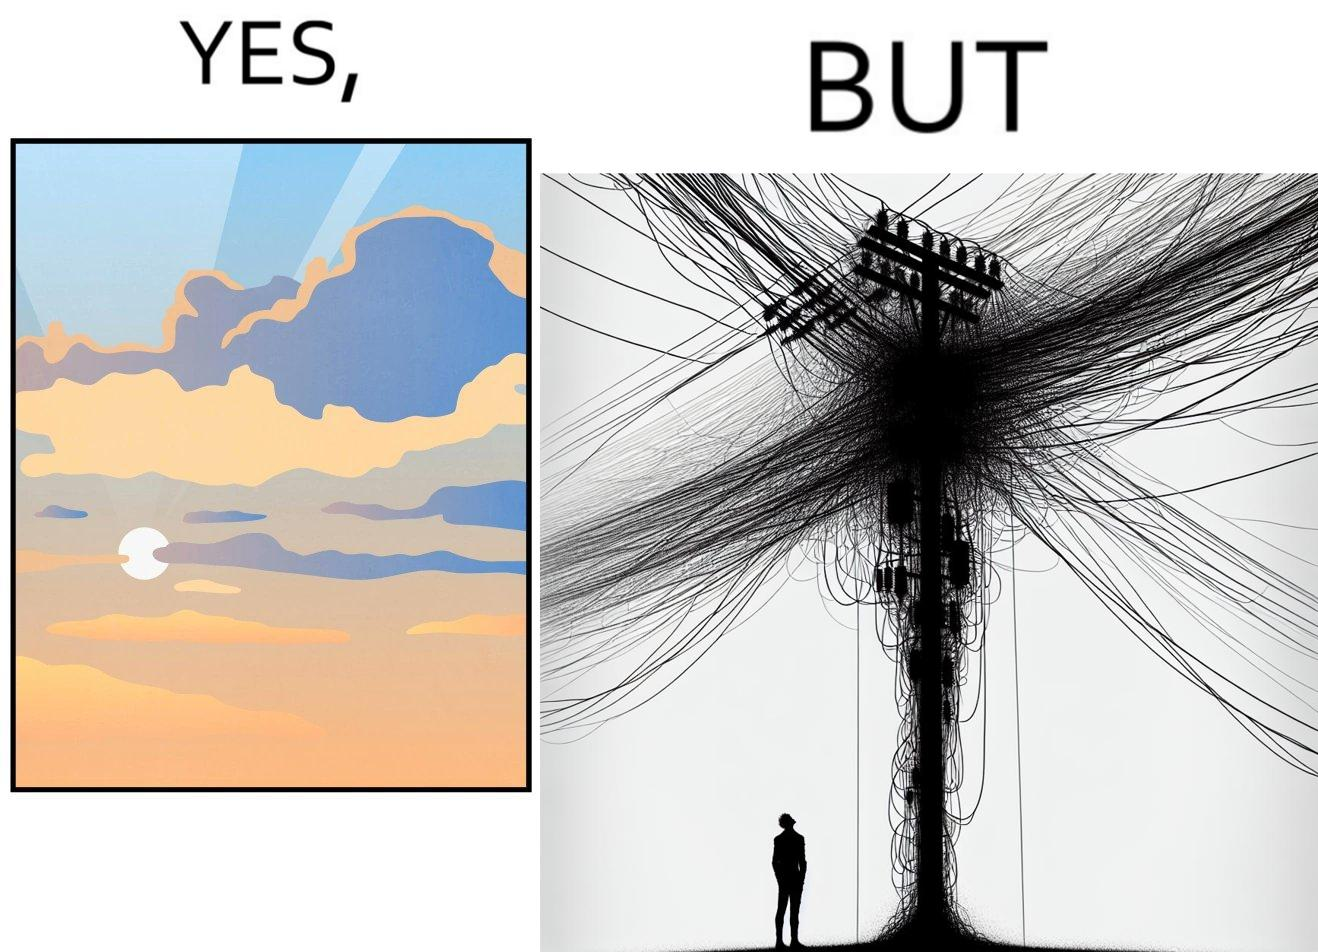Provide a description of this image. The image is ironic, because in the first image clear sky is visible but in the second image the same view is getting blocked due to the electricity pole 